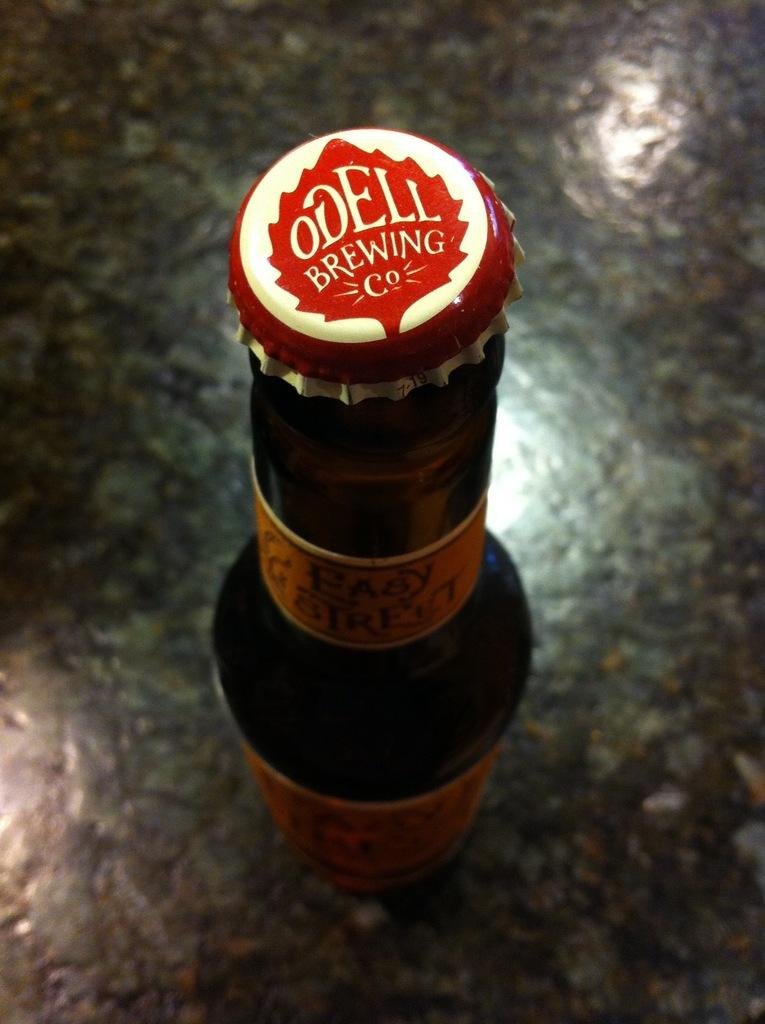<image>
Write a terse but informative summary of the picture. A bottle of Odell brewing co beer features a white a cap with a red leaf 